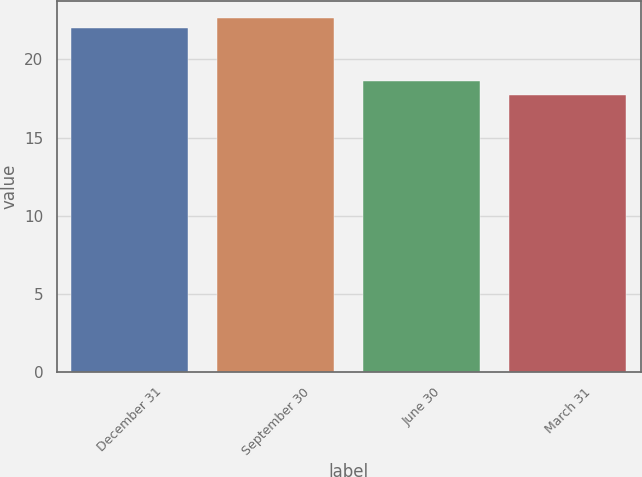Convert chart. <chart><loc_0><loc_0><loc_500><loc_500><bar_chart><fcel>December 31<fcel>September 30<fcel>June 30<fcel>March 31<nl><fcel>22<fcel>22.63<fcel>18.63<fcel>17.75<nl></chart> 